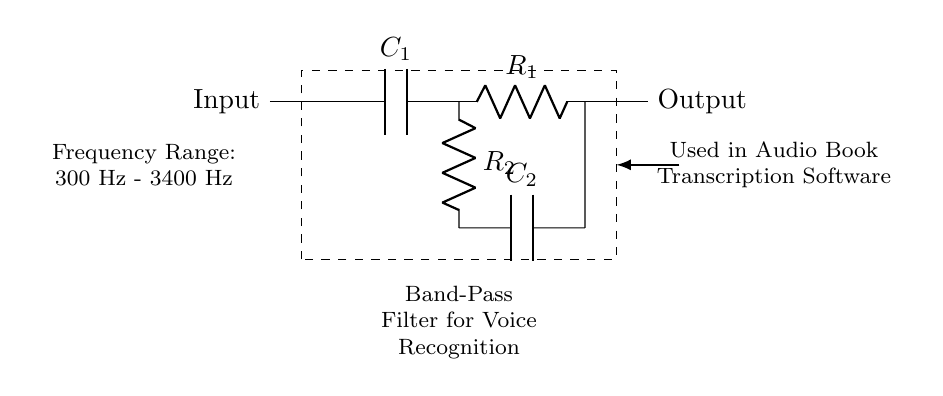What type of filter is represented in this circuit? This circuit is specifically designed as a band-pass filter, as indicated in the label at the bottom of the circuit diagram, which states its purpose.
Answer: Band-Pass Filter What components are used in the circuit? The circuit comprises two resistors (R1 and R2) and two capacitors (C1 and C2) as visible in the diagram.
Answer: Resistors and Capacitors What is the frequency range of the filter? The circuit diagram states a frequency range of 300 Hz to 3400 Hz, which is specified within the label seen at the left side of the diagram.
Answer: 300 Hz - 3400 Hz How many capacitors are present in the circuit? By examining the circuit, it is clear that there are two capacitors labeled as C1 and C2, visually connected in the circuit setup.
Answer: Two What is the purpose of this band-pass filter in relation to audio? The purpose of this filter is stated as being used in audio book transcription software, indicating its role in processing voice frequencies accurately.
Answer: Voice Recognition How do the resistors influence the performance of the band-pass filter? The resistors (R1 and R2) determine the cutoff frequencies when combined with the capacitors. This affects which frequencies are allowed to pass through and which are attenuated in the filtering process.
Answer: Cutoff Frequencies 